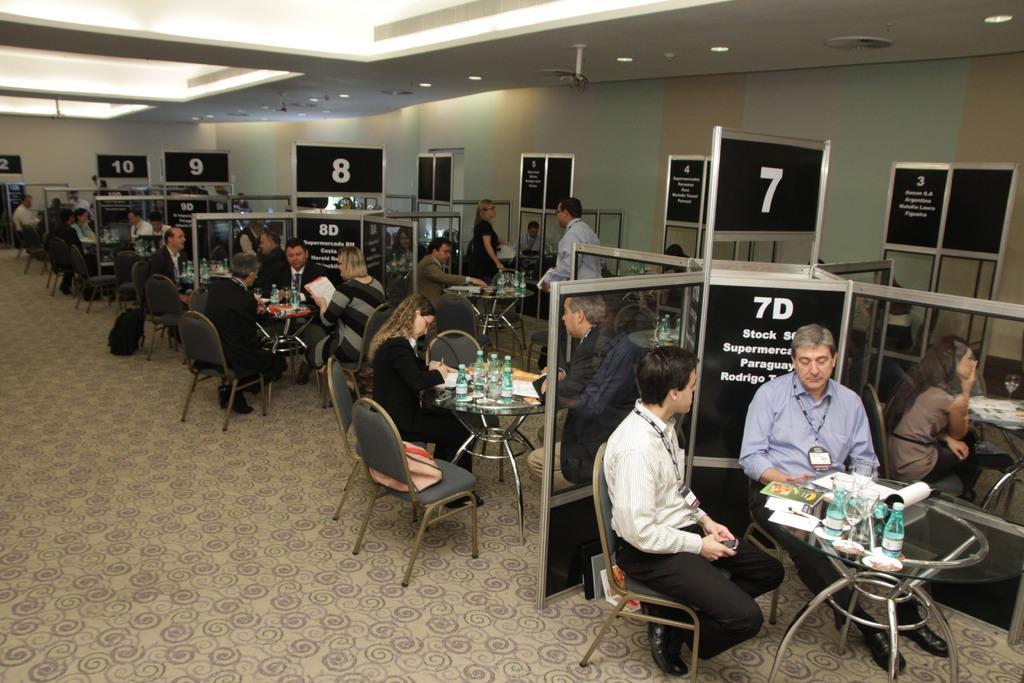How would you summarize this image in a sentence or two? In this image their are different blocks based on the numbering given on the top of block. Each block have two to three members who are sitting around the round table. On the table there are bottles,papers,files. At the top there is ceiling with lights. To the top right corner there is wall. At the bottom there is floor which is covered with the carpet. 